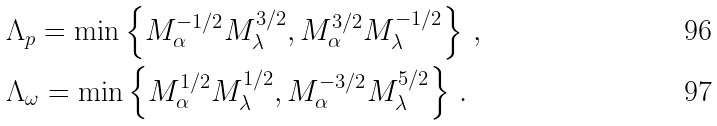Convert formula to latex. <formula><loc_0><loc_0><loc_500><loc_500>& \Lambda _ { p } = \min \left \{ M _ { \alpha } ^ { - 1 / 2 } M _ { \lambda } ^ { 3 / 2 } , M _ { \alpha } ^ { 3 / 2 } M _ { \lambda } ^ { - 1 / 2 } \right \} \, , \\ & \Lambda _ { \omega } = \min \left \{ { M _ { \alpha } ^ { 1 / 2 } M _ { \lambda } ^ { 1 / 2 } } , M _ { \alpha } ^ { - 3 / 2 } M _ { \lambda } ^ { 5 / 2 } \right \} \, .</formula> 